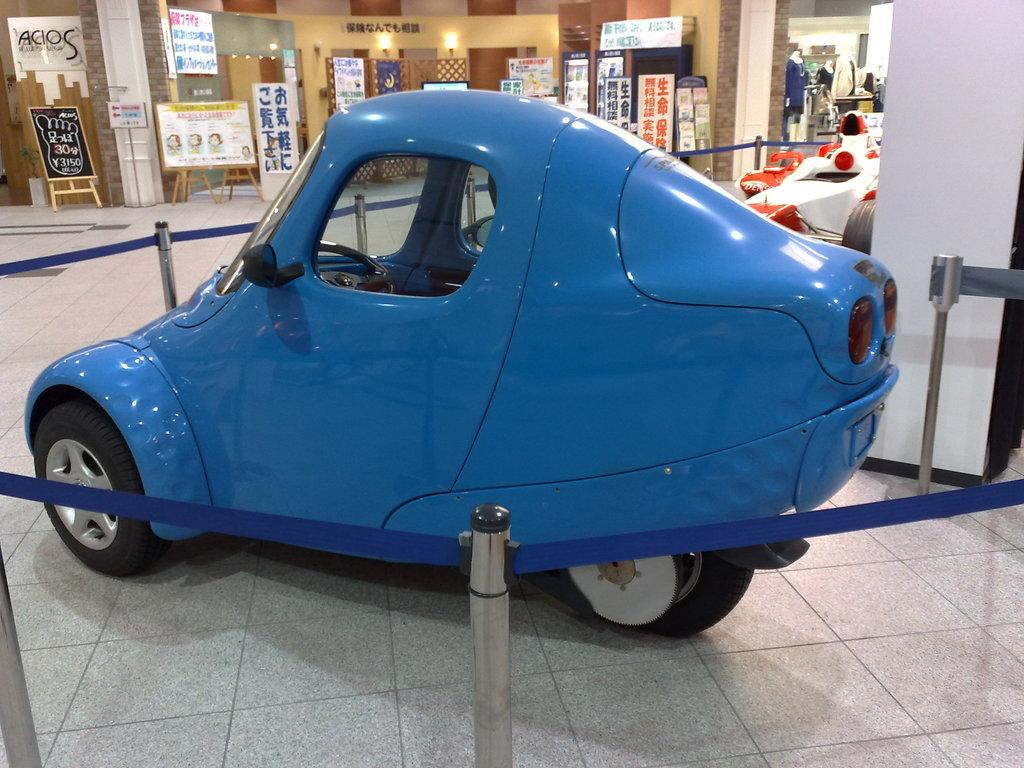What object is placed on the floor in the image? There is a car on the floor in the image. What surrounds the car in the image? There is a railing around the car. What can be seen in the background of the image? In the background of the image, there are boards with text and shops visible. What type of donkey can be seen coughing in the image? There is no donkey present in the image, and therefore no such activity can be observed. 